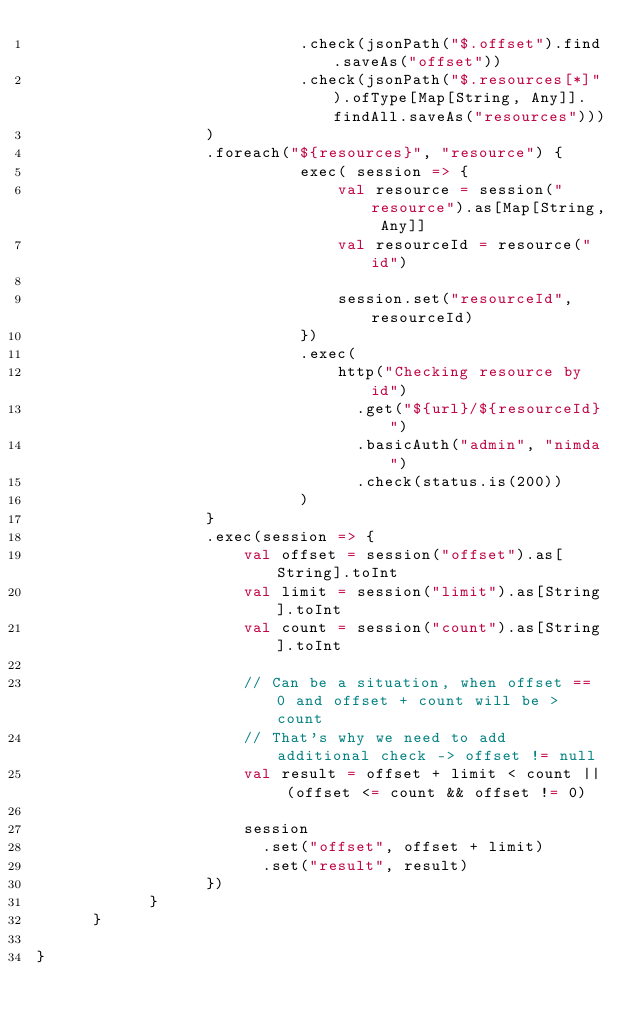<code> <loc_0><loc_0><loc_500><loc_500><_Scala_>                            .check(jsonPath("$.offset").find.saveAs("offset"))            
                            .check(jsonPath("$.resources[*]").ofType[Map[String, Any]].findAll.saveAs("resources")))                  
                  )
                  .foreach("${resources}", "resource") {
                            exec( session => {
                                val resource = session("resource").as[Map[String, Any]]
                                val resourceId = resource("id")
                                
                                session.set("resourceId", resourceId)
                            })
                            .exec(
                                http("Checking resource by id")
                                  .get("${url}/${resourceId}")
                                  .basicAuth("admin", "nimda")
                                  .check(status.is(200))
                            )
                  }
                  .exec(session => {
                      val offset = session("offset").as[String].toInt
                      val limit = session("limit").as[String].toInt
                      val count = session("count").as[String].toInt

                      // Can be a situation, when offset == 0 and offset + count will be > count
                      // That's why we need to add additional check -> offset != null
                      val result = offset + limit < count || (offset <= count && offset != 0)
                      
                      session
                        .set("offset", offset + limit)
                        .set("result", result)
                  })
            }
      }    
    
}</code> 